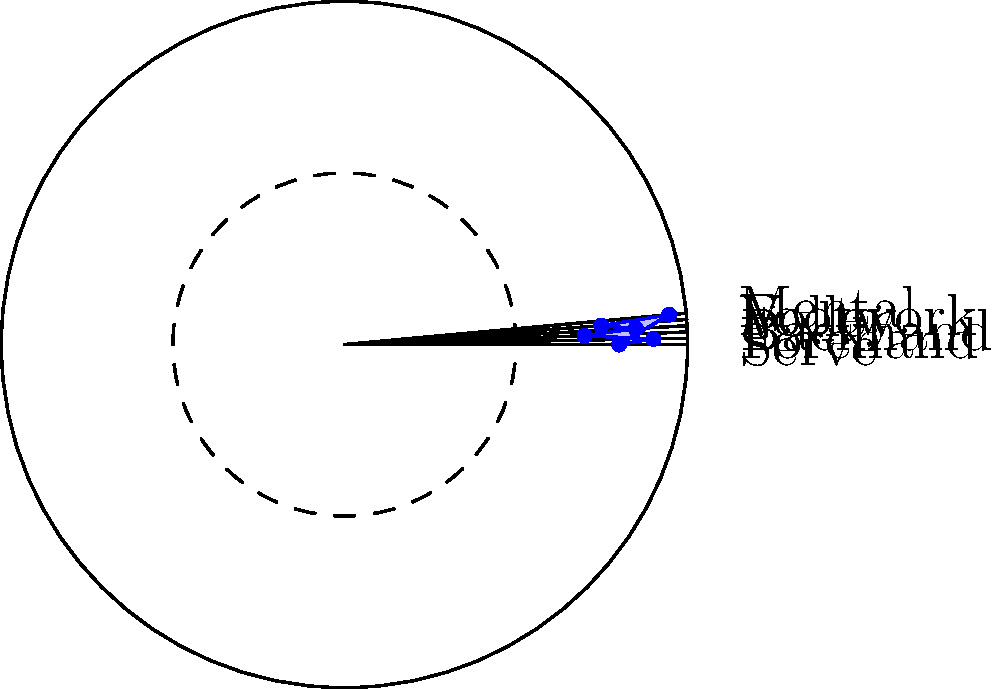As a sales agent who enjoys watching tennis, you come across a radar chart analyzing a player's performance. The chart shows six attributes: Serve, Forehand, Backhand, Volley, Footwork, and Mental. If the player wants to improve their overall game by focusing on their two weakest areas, which skills should they prioritize? To determine the two weakest areas, we need to analyze the radar chart step by step:

1. Identify all six attributes:
   - Serve
   - Forehand
   - Backhand
   - Volley
   - Footwork
   - Mental

2. Estimate the values for each attribute (on a scale of 0 to 1):
   - Serve: 0.8
   - Forehand: 0.9
   - Backhand: 0.7
   - Volley: 0.85
   - Footwork: 0.75
   - Mental: 0.95

3. Rank the attributes from lowest to highest:
   1. Backhand (0.7)
   2. Footwork (0.75)
   3. Serve (0.8)
   4. Volley (0.85)
   5. Forehand (0.9)
   6. Mental (0.95)

4. Identify the two lowest-ranking attributes:
   - Backhand (0.7)
   - Footwork (0.75)

Therefore, to improve their overall game, the player should focus on enhancing their Backhand and Footwork skills, as these are the two weakest areas according to the radar chart.
Answer: Backhand and Footwork 